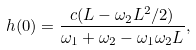Convert formula to latex. <formula><loc_0><loc_0><loc_500><loc_500>h ( 0 ) = \frac { c ( L - \omega _ { 2 } L ^ { 2 } / 2 ) } { \omega _ { 1 } + \omega _ { 2 } - \omega _ { 1 } \omega _ { 2 } L } ,</formula> 